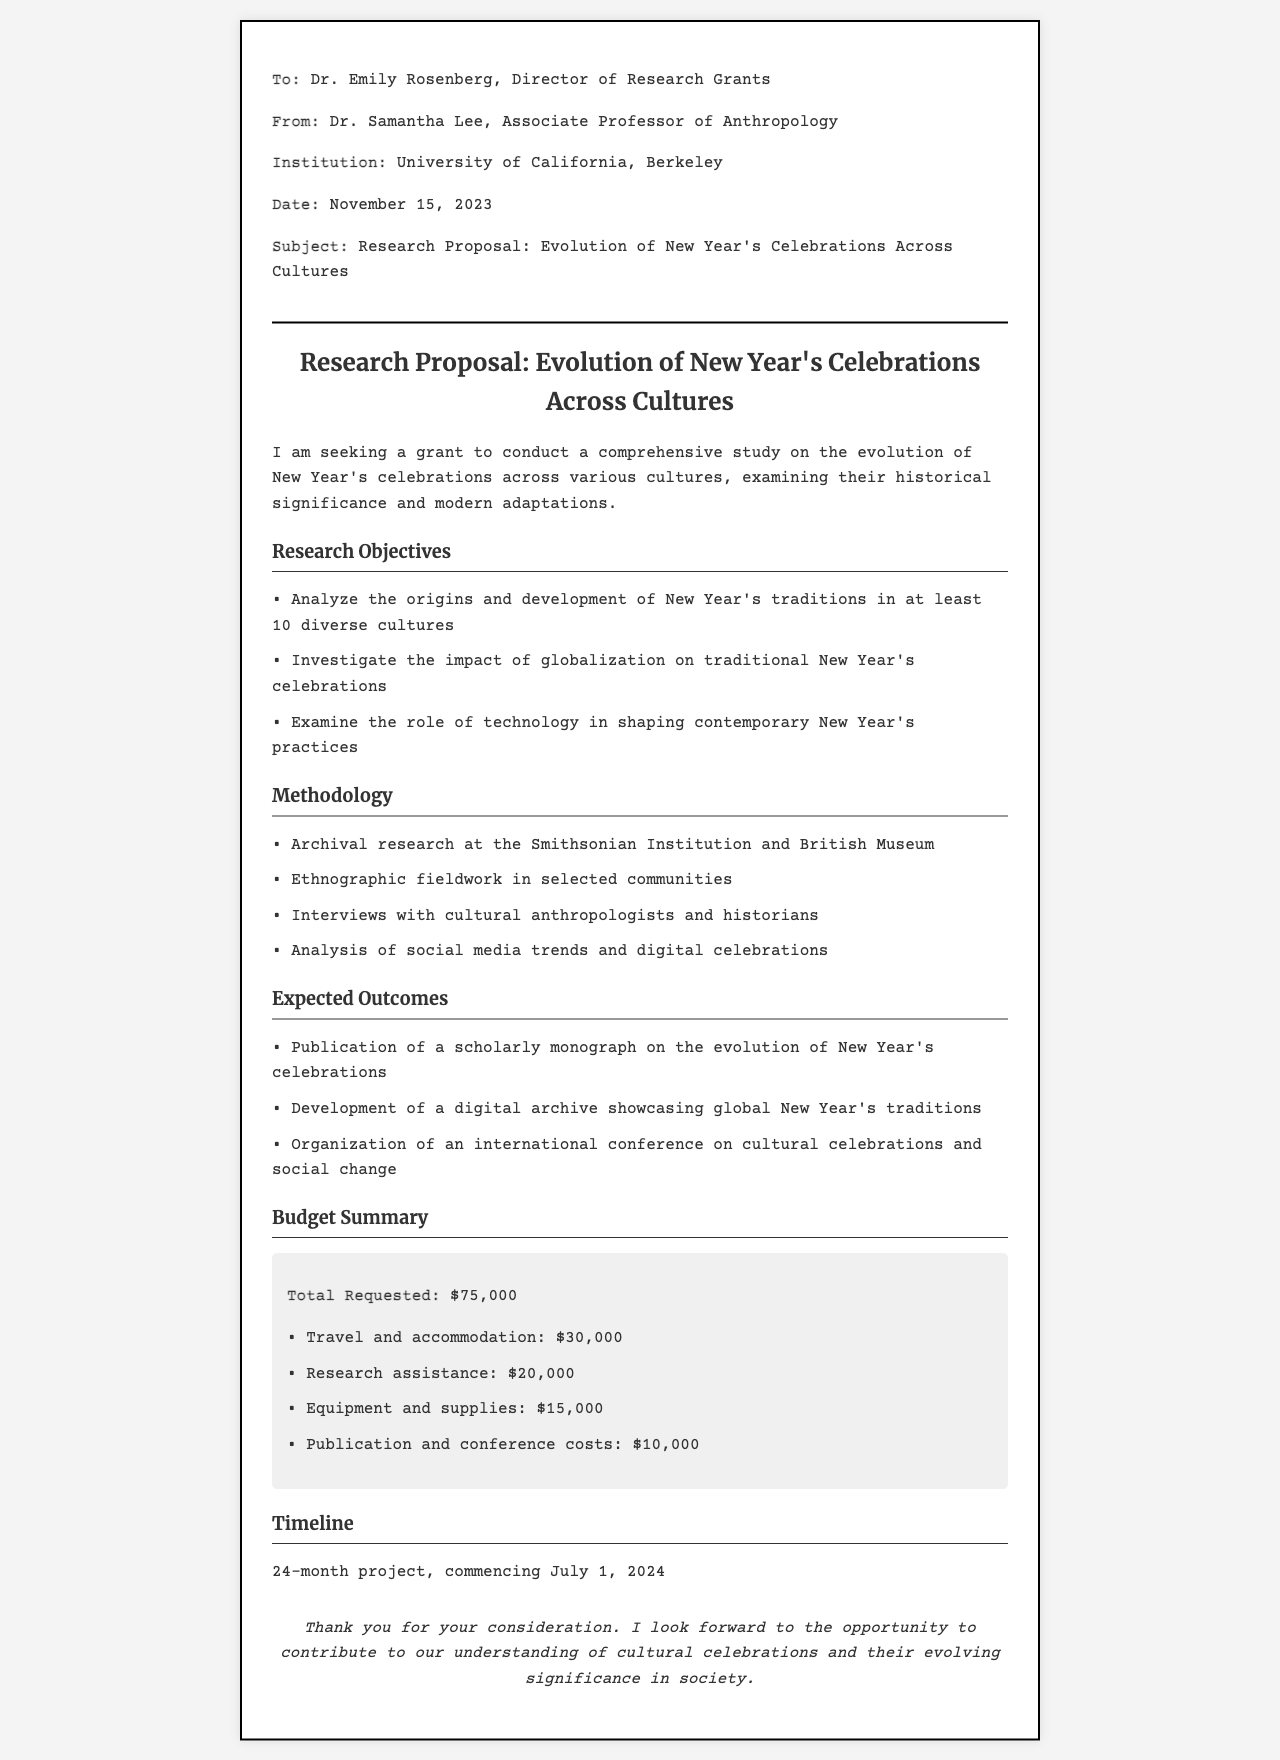what is the total requested budget? The total requested budget is clearly stated in the budget summary section.
Answer: $75,000 who is the principal investigator of the research proposal? The principal investigator is identified in the from section of the fax.
Answer: Dr. Samantha Lee what are the three main research objectives listed? The research objectives are outlined in a bullet list, summarizing the main areas of focus.
Answer: Analyze the origins and development, investigate the impact of globalization, examine the role of technology when is the project scheduled to commence? The timeline section specifies the start date of the project.
Answer: July 1, 2024 how many cultures will be analyzed in the study? The document specifies a minimum number of cultures to be analyzed in the objectives section.
Answer: at least 10 what type of research will be conducted at the Smithsonian Institution? The methodology section mentions the type of research planned at this institution.
Answer: Archival research what is one expected outcome of the study? The expected outcomes are listed, providing insight into the goals of the research project.
Answer: Publication of a scholarly monograph how long is the proposed project timeline? The timeline section indicates the duration of the project.
Answer: 24-month project 